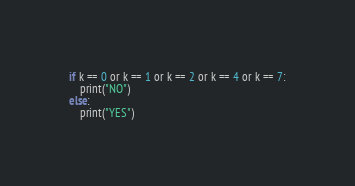Convert code to text. <code><loc_0><loc_0><loc_500><loc_500><_Python_>if k == 0 or k == 1 or k == 2 or k == 4 or k == 7:
    print("NO")
else:
    print("YES")
</code> 